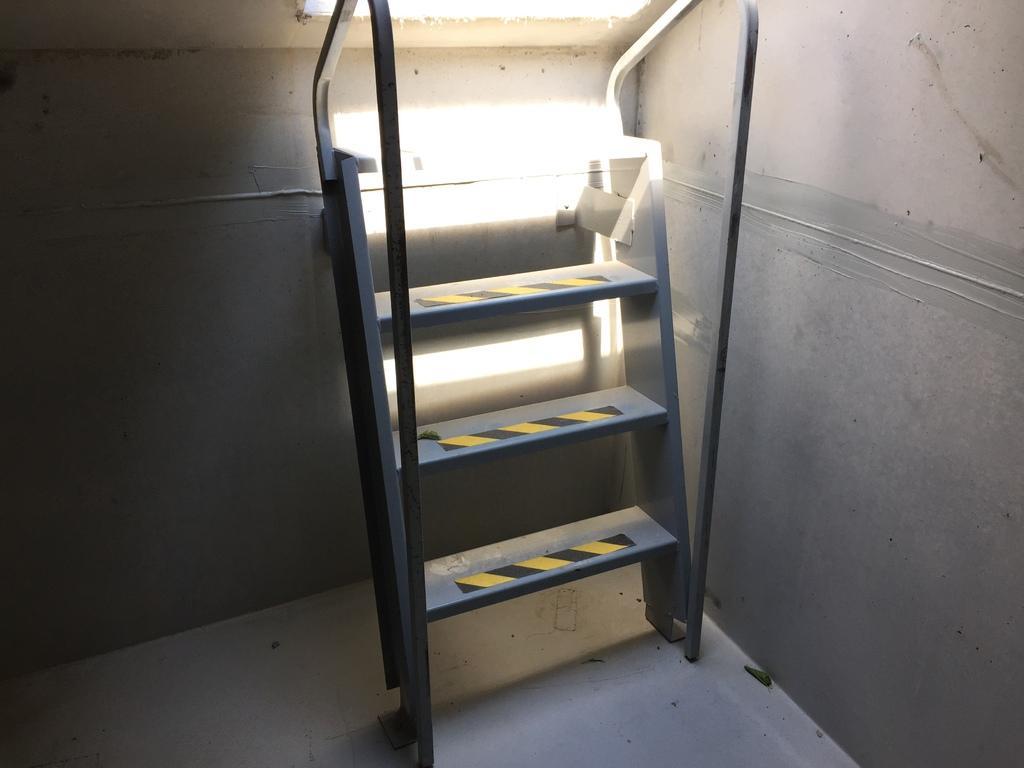Could you give a brief overview of what you see in this image? In this image I can see the iron ladder and I can see the wall in cream color. 